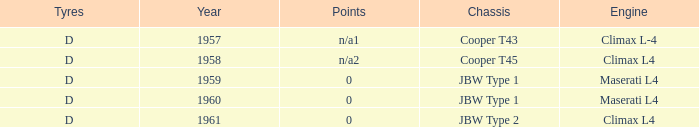What is the tyres with a year earlier than 1961 for a climax l4 engine? D. 